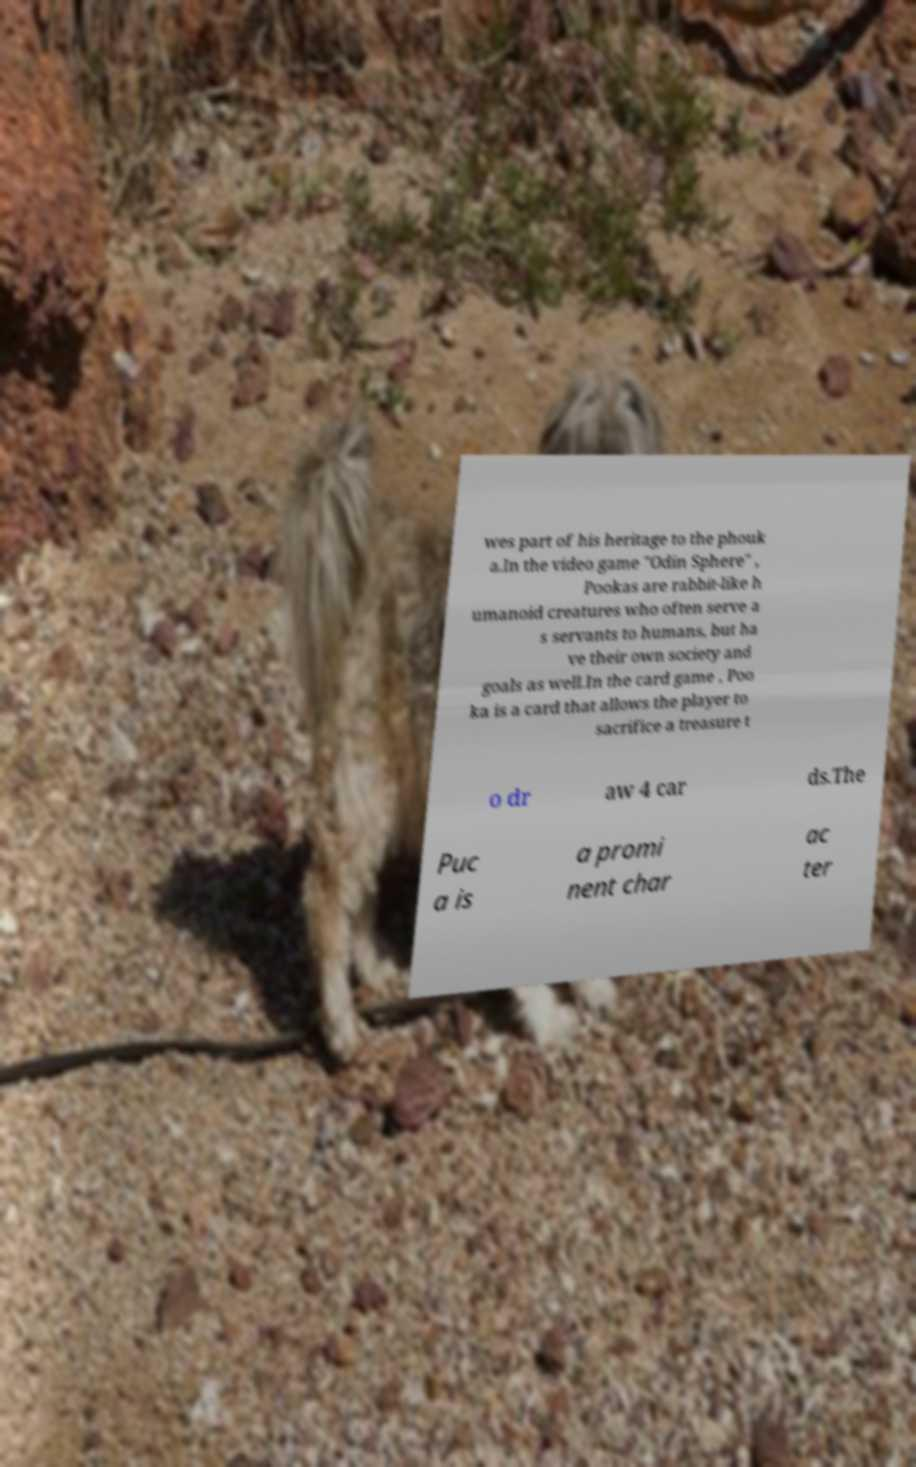I need the written content from this picture converted into text. Can you do that? wes part of his heritage to the phouk a.In the video game "Odin Sphere" , Pookas are rabbit-like h umanoid creatures who often serve a s servants to humans, but ha ve their own society and goals as well.In the card game , Poo ka is a card that allows the player to sacrifice a treasure t o dr aw 4 car ds.The Puc a is a promi nent char ac ter 